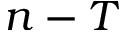Convert formula to latex. <formula><loc_0><loc_0><loc_500><loc_500>n - T</formula> 